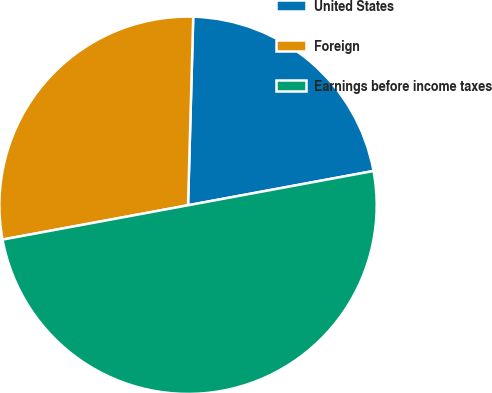Convert chart to OTSL. <chart><loc_0><loc_0><loc_500><loc_500><pie_chart><fcel>United States<fcel>Foreign<fcel>Earnings before income taxes<nl><fcel>21.65%<fcel>28.35%<fcel>50.0%<nl></chart> 